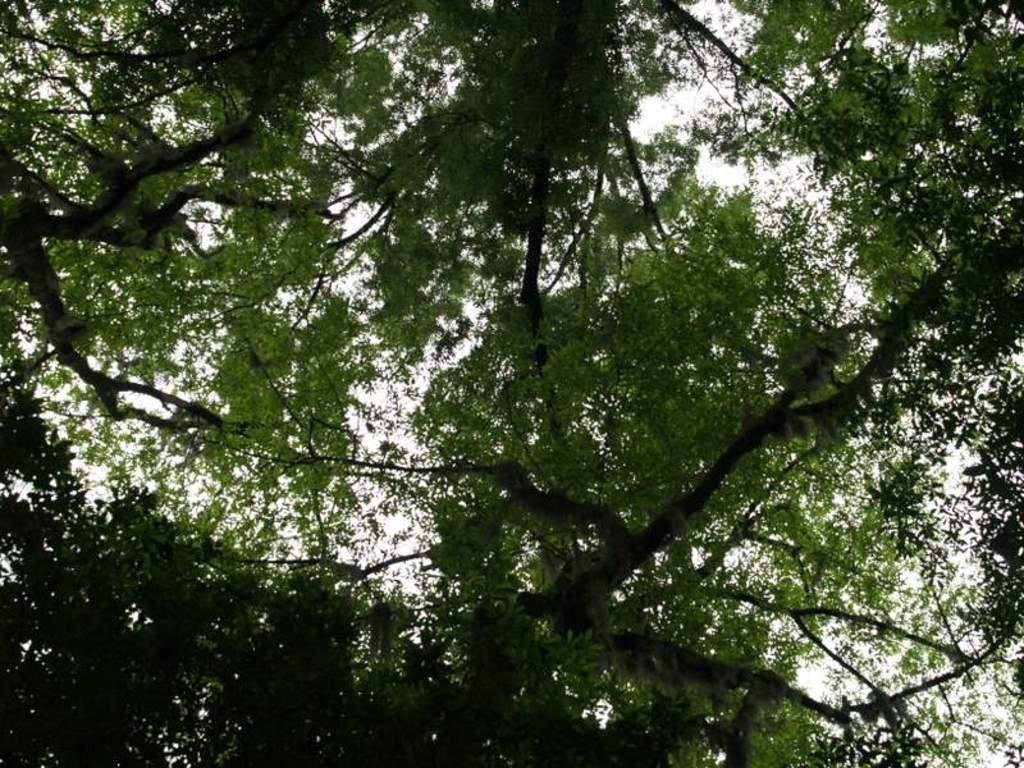What type of vegetation can be seen in the image? There are trees in the image. How much of the trees can be seen in the image? The trees are truncated, meaning they are partially visible. What else is visible in the image besides the trees? There is sky visible in the image. How much of the sky can be seen in the image? The sky is truncated, meaning it is partially visible. Can you see a donkey using a fork to eat in the image? There is no donkey or fork present in the image. 